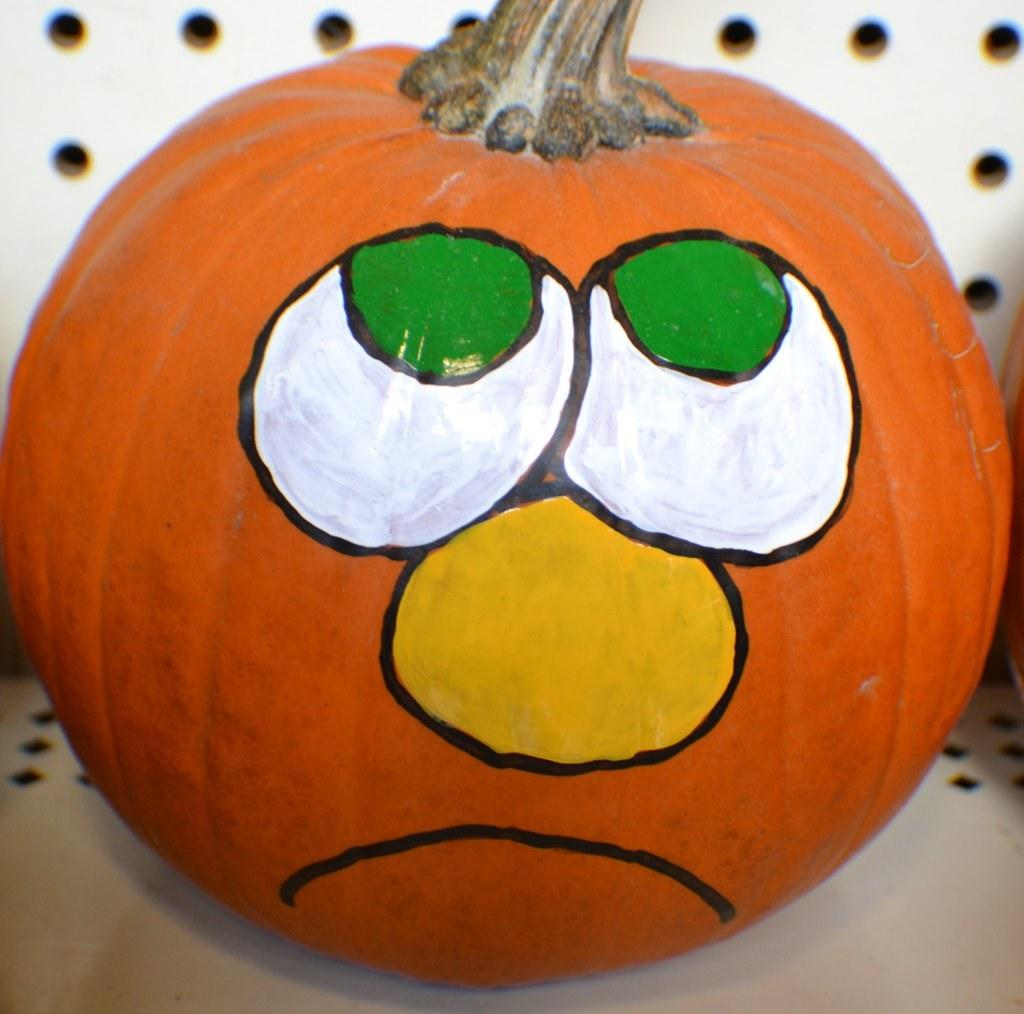What is the main object in the image? There is a pumpkin in the image. Where is the pumpkin located? The pumpkin is on a table. What is done to the pumpkin in the image? The pumpkin has some painting on it. What type of jeans is the pumpkin wearing in the image? Pumpkins do not wear jeans, as they are a type of vegetable and not capable of wearing clothing. 